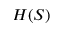<formula> <loc_0><loc_0><loc_500><loc_500>H ( S )</formula> 